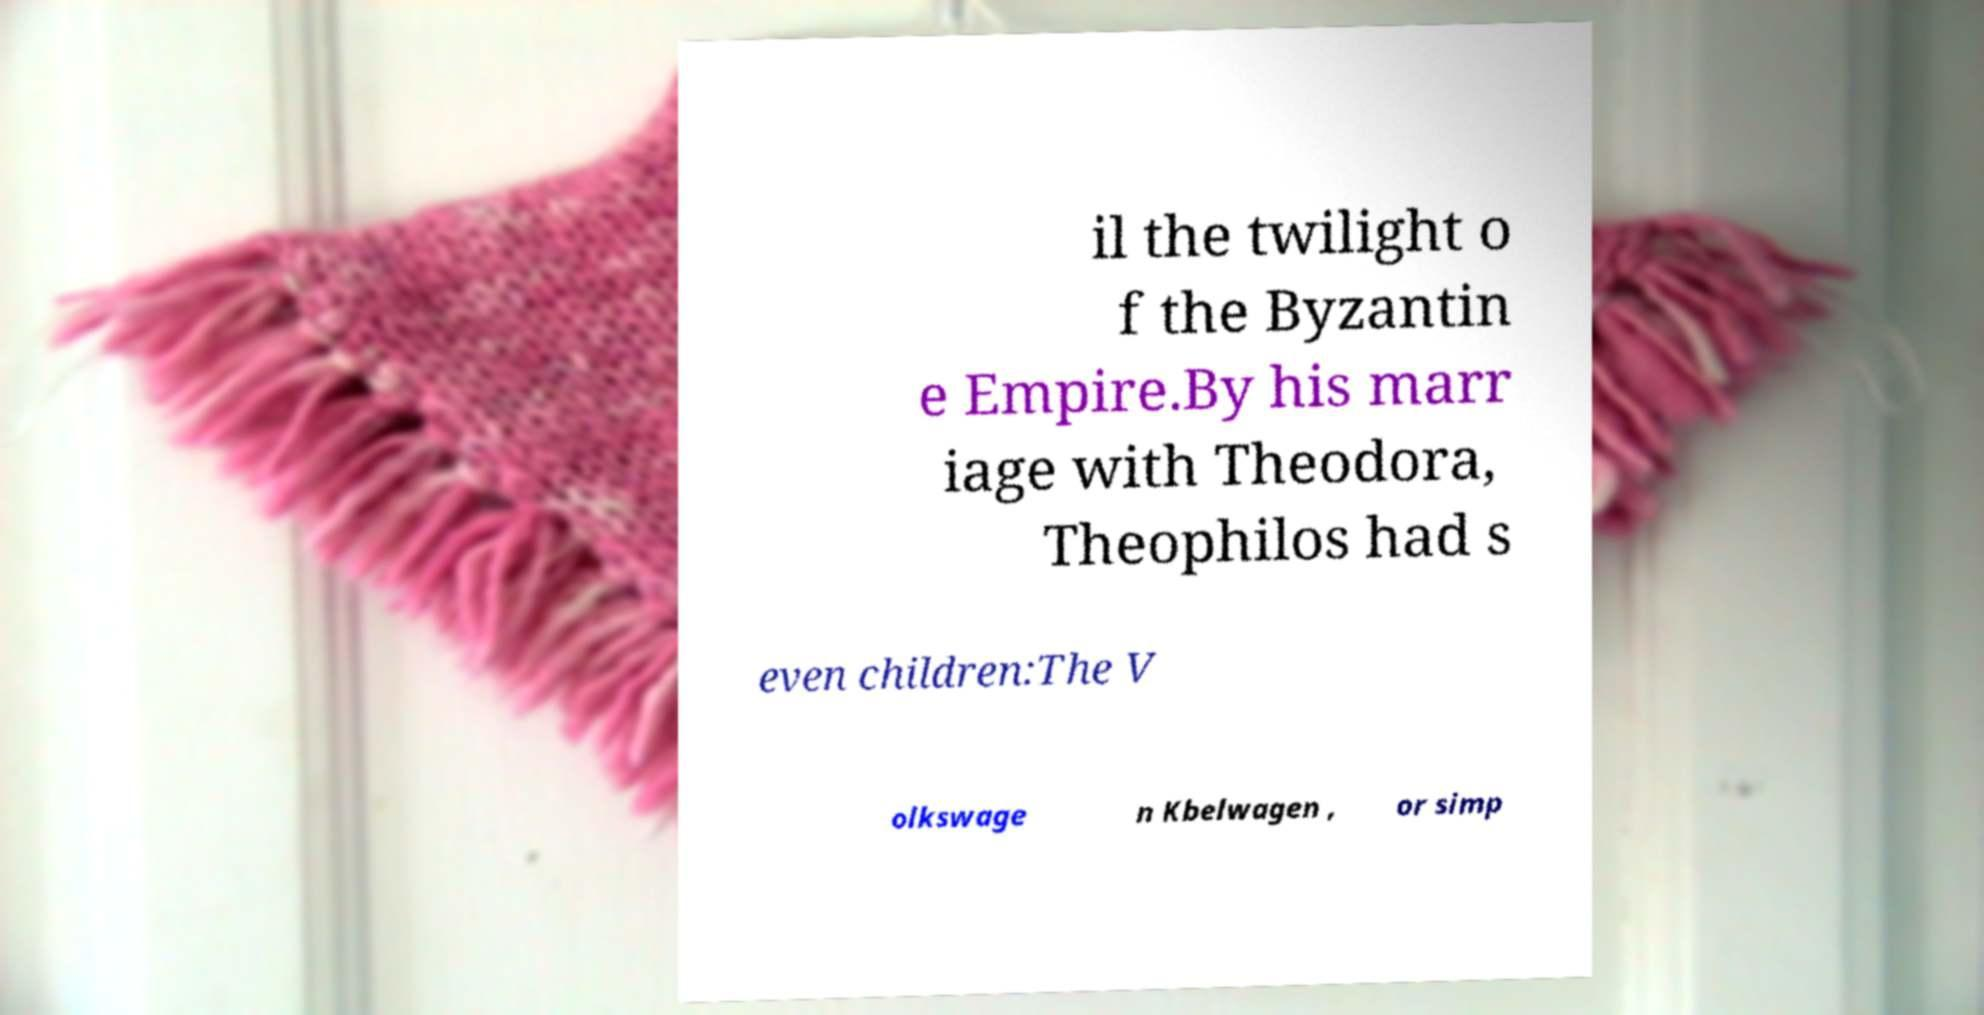Please read and relay the text visible in this image. What does it say? il the twilight o f the Byzantin e Empire.By his marr iage with Theodora, Theophilos had s even children:The V olkswage n Kbelwagen , or simp 